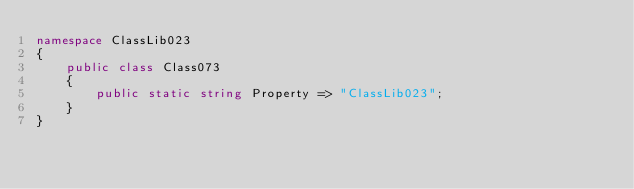<code> <loc_0><loc_0><loc_500><loc_500><_C#_>namespace ClassLib023
{
    public class Class073
    {
        public static string Property => "ClassLib023";
    }
}
</code> 